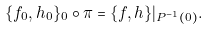<formula> <loc_0><loc_0><loc_500><loc_500>\{ f _ { 0 } , h _ { 0 } \} _ { 0 } \circ \pi = \{ f , h \} | _ { P ^ { - 1 } ( 0 ) } .</formula> 